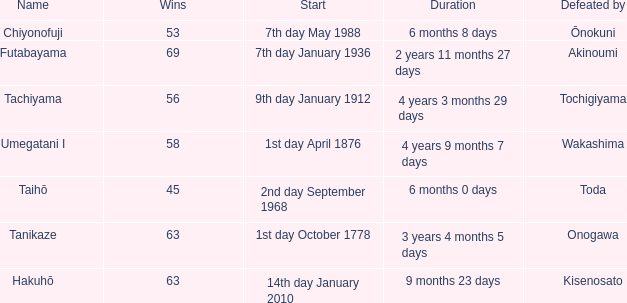How many wins were held before being defeated by toda? 1.0. 